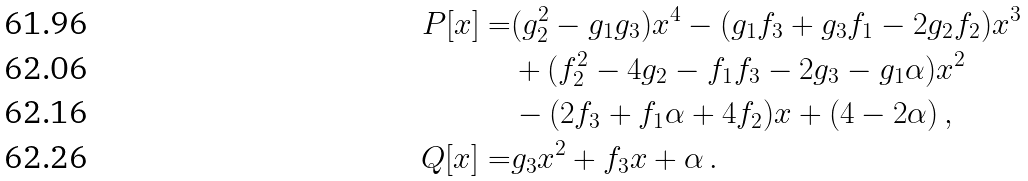<formula> <loc_0><loc_0><loc_500><loc_500>P [ x ] = & ( g ^ { 2 } _ { 2 } - g _ { 1 } g _ { 3 } ) x ^ { 4 } - ( g _ { 1 } f _ { 3 } + g _ { 3 } f _ { 1 } - 2 g _ { 2 } f _ { 2 } ) x ^ { 3 } \\ & + ( f _ { 2 } ^ { 2 } - 4 g _ { 2 } - f _ { 1 } f _ { 3 } - 2 g _ { 3 } - g _ { 1 } \alpha ) x ^ { 2 } \\ & - ( 2 f _ { 3 } + f _ { 1 } \alpha + 4 f _ { 2 } ) x + ( 4 - 2 \alpha ) \, , \\ Q [ x ] = & g _ { 3 } x ^ { 2 } + f _ { 3 } x + \alpha \, .</formula> 